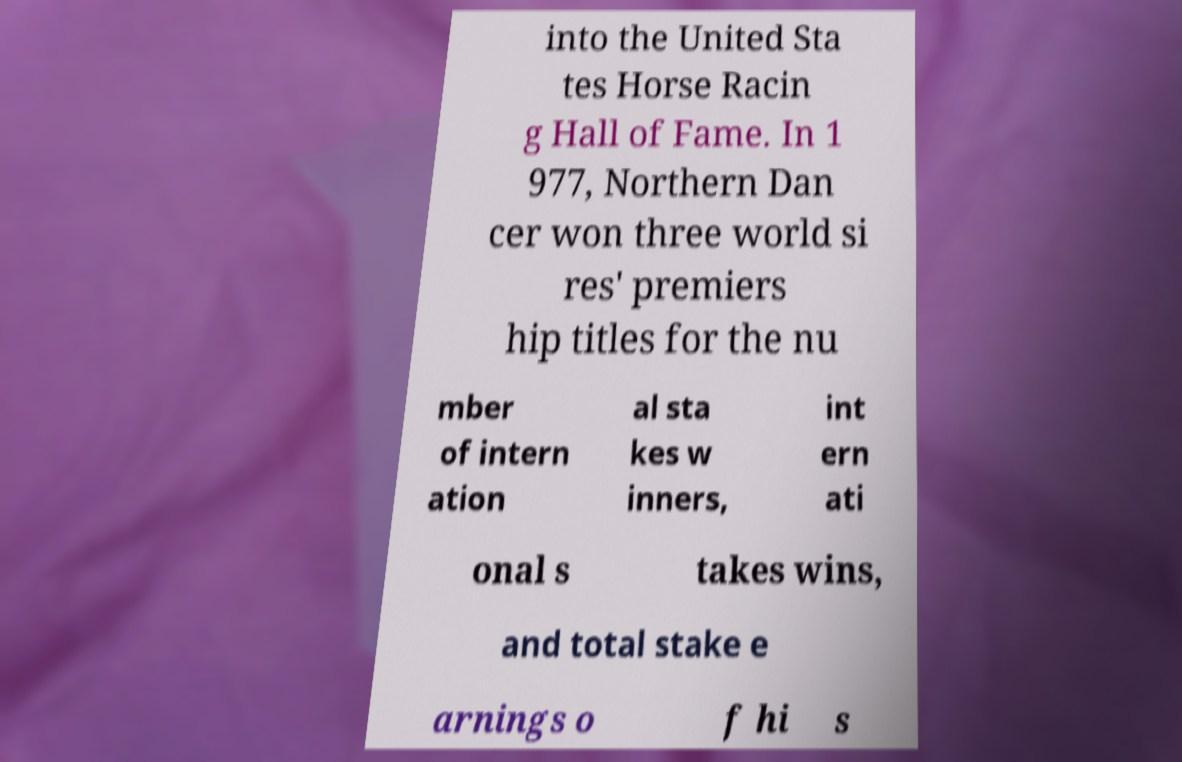Can you read and provide the text displayed in the image?This photo seems to have some interesting text. Can you extract and type it out for me? into the United Sta tes Horse Racin g Hall of Fame. In 1 977, Northern Dan cer won three world si res' premiers hip titles for the nu mber of intern ation al sta kes w inners, int ern ati onal s takes wins, and total stake e arnings o f hi s 